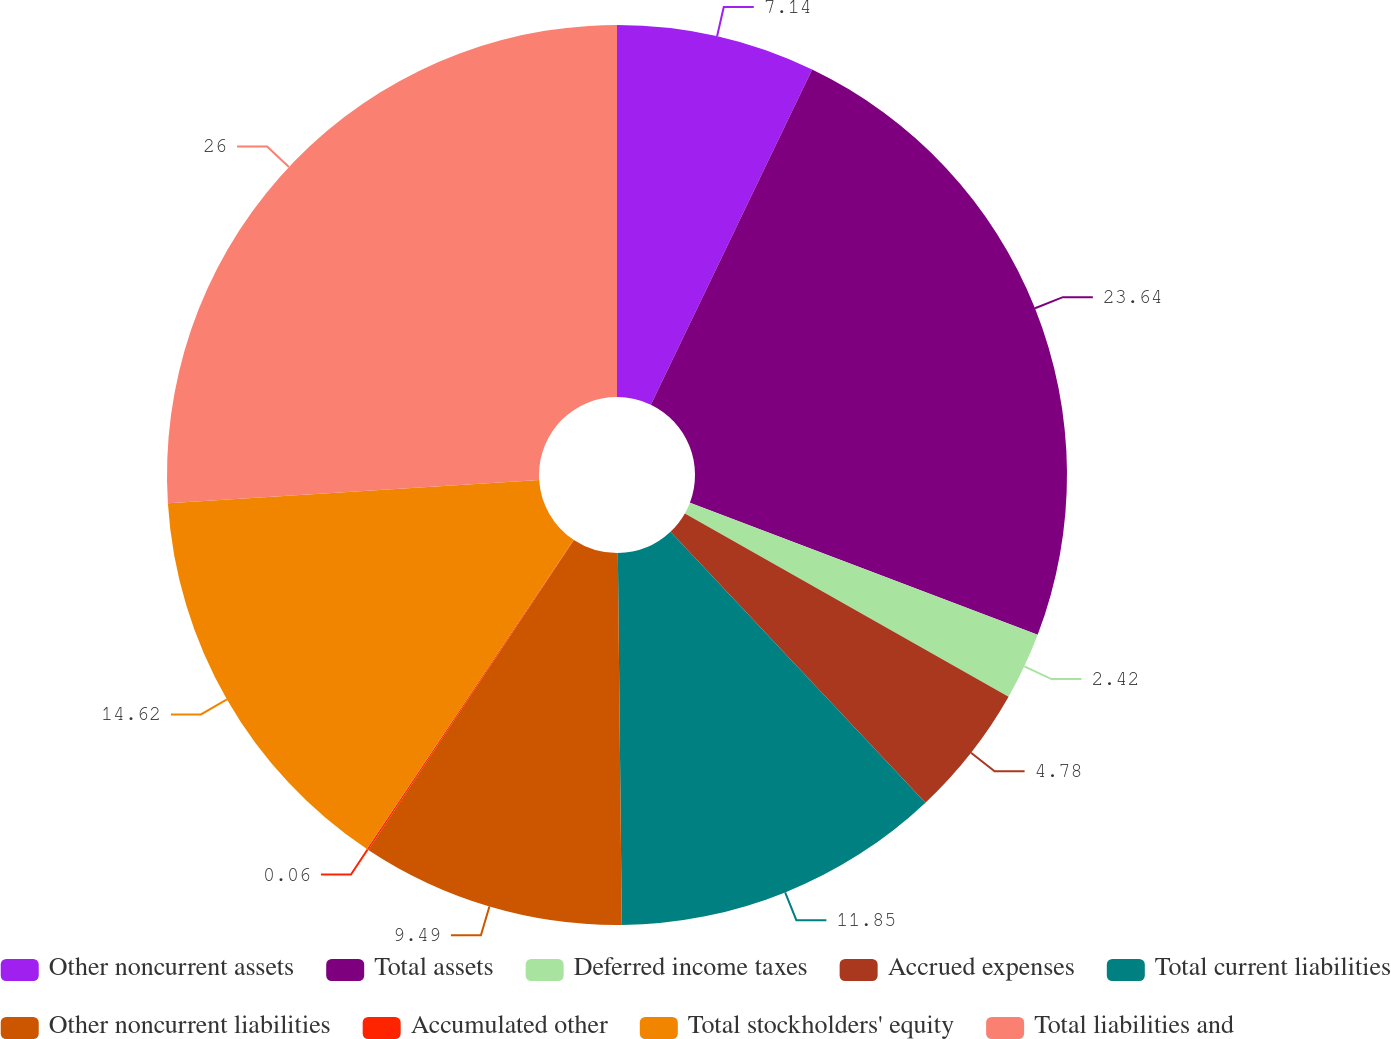<chart> <loc_0><loc_0><loc_500><loc_500><pie_chart><fcel>Other noncurrent assets<fcel>Total assets<fcel>Deferred income taxes<fcel>Accrued expenses<fcel>Total current liabilities<fcel>Other noncurrent liabilities<fcel>Accumulated other<fcel>Total stockholders' equity<fcel>Total liabilities and<nl><fcel>7.14%<fcel>23.64%<fcel>2.42%<fcel>4.78%<fcel>11.85%<fcel>9.49%<fcel>0.06%<fcel>14.62%<fcel>26.0%<nl></chart> 